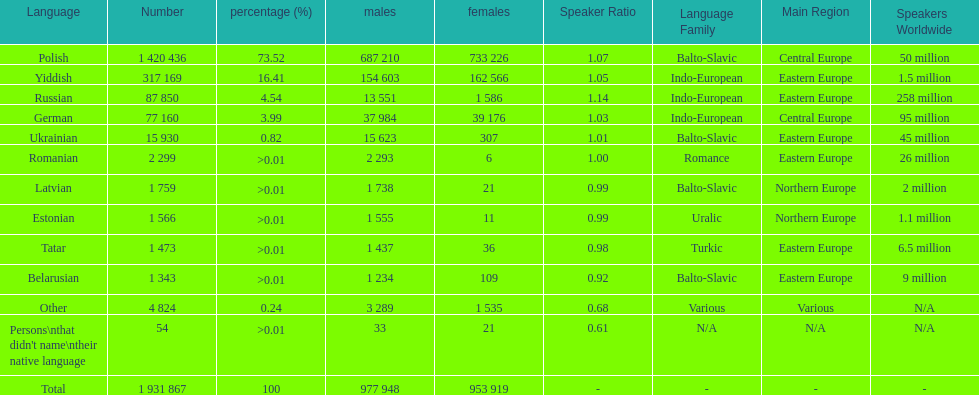In which language is the female speaker population the smallest? Romanian. 